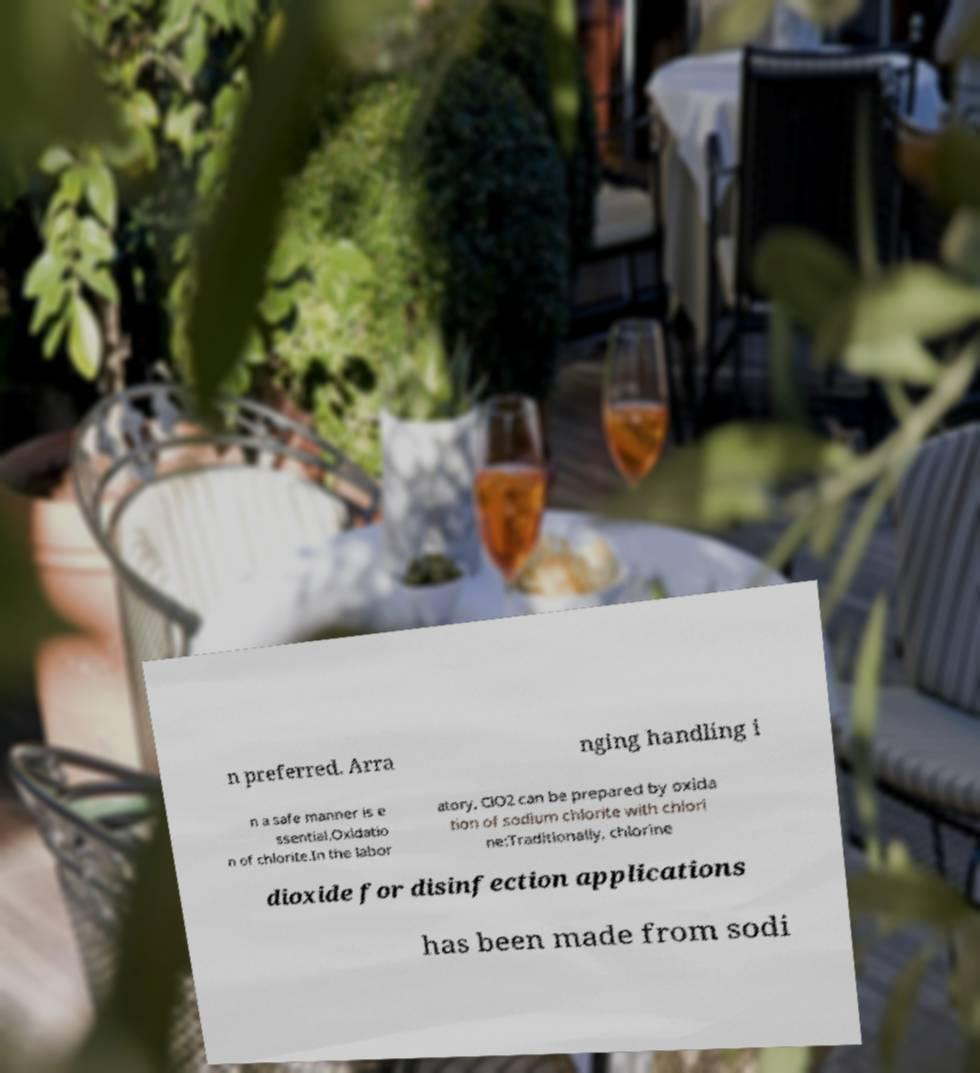Can you accurately transcribe the text from the provided image for me? n preferred. Arra nging handling i n a safe manner is e ssential.Oxidatio n of chlorite.In the labor atory, ClO2 can be prepared by oxida tion of sodium chlorite with chlori ne:Traditionally, chlorine dioxide for disinfection applications has been made from sodi 